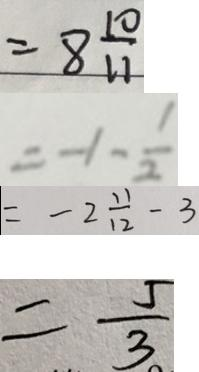Convert formula to latex. <formula><loc_0><loc_0><loc_500><loc_500>= 8 \frac { 1 0 } { 1 1 } 
 = - 1 - \frac { 1 } { 2 } 
 = - 2 \frac { 1 1 } { 1 2 } - 3 
 = \frac { 5 } { 3 }</formula> 